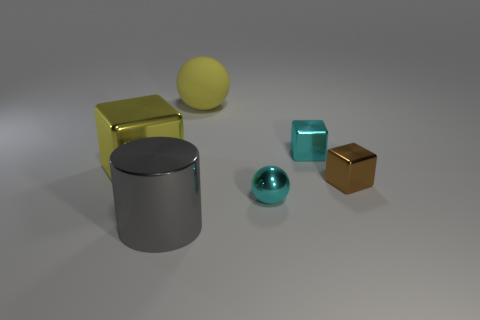What is the material of the block that is the same color as the matte object?
Give a very brief answer. Metal. What number of objects are either large metallic things behind the big gray cylinder or metallic objects?
Make the answer very short. 5. There is a metal thing that is the same size as the metallic cylinder; what shape is it?
Your answer should be compact. Cube. There is a yellow object that is on the left side of the large gray shiny cylinder; is its size the same as the cyan object that is in front of the cyan cube?
Provide a succinct answer. No. What is the color of the cylinder that is made of the same material as the cyan sphere?
Your response must be concise. Gray. Does the cyan object that is in front of the small cyan metallic block have the same material as the large thing to the right of the cylinder?
Provide a succinct answer. No. Is there a yellow ball of the same size as the metal cylinder?
Your response must be concise. Yes. What size is the cube that is on the left side of the cyan object that is in front of the brown shiny block?
Your response must be concise. Large. What number of large blocks have the same color as the large matte sphere?
Offer a terse response. 1. What shape is the tiny shiny object behind the big thing on the left side of the gray metal object?
Your answer should be very brief. Cube. 